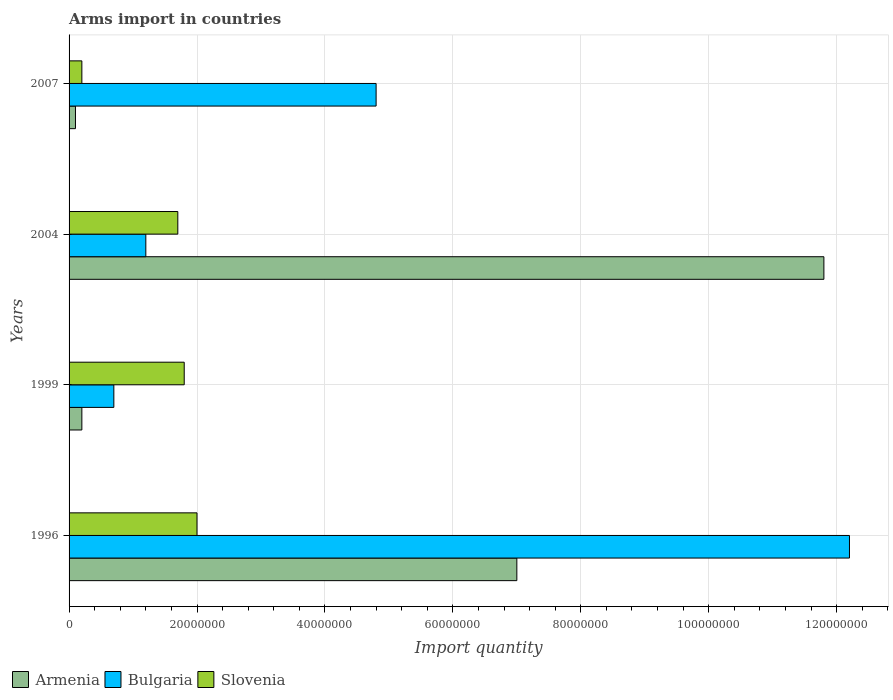How many groups of bars are there?
Your answer should be very brief. 4. Are the number of bars per tick equal to the number of legend labels?
Offer a terse response. Yes. How many bars are there on the 4th tick from the top?
Your answer should be compact. 3. How many bars are there on the 1st tick from the bottom?
Provide a succinct answer. 3. What is the label of the 3rd group of bars from the top?
Provide a succinct answer. 1999. What is the total arms import in Slovenia in 1999?
Offer a terse response. 1.80e+07. Across all years, what is the maximum total arms import in Armenia?
Your answer should be compact. 1.18e+08. Across all years, what is the minimum total arms import in Armenia?
Provide a short and direct response. 1.00e+06. In which year was the total arms import in Bulgaria maximum?
Make the answer very short. 1996. What is the total total arms import in Armenia in the graph?
Your answer should be compact. 1.91e+08. What is the difference between the total arms import in Armenia in 1999 and that in 2007?
Your response must be concise. 1.00e+06. What is the difference between the total arms import in Bulgaria in 2004 and the total arms import in Slovenia in 1999?
Offer a terse response. -6.00e+06. What is the average total arms import in Slovenia per year?
Your answer should be very brief. 1.42e+07. In the year 2004, what is the difference between the total arms import in Slovenia and total arms import in Armenia?
Provide a succinct answer. -1.01e+08. What is the ratio of the total arms import in Armenia in 2004 to that in 2007?
Keep it short and to the point. 118. What is the difference between the highest and the lowest total arms import in Armenia?
Your response must be concise. 1.17e+08. In how many years, is the total arms import in Bulgaria greater than the average total arms import in Bulgaria taken over all years?
Your response must be concise. 2. Is the sum of the total arms import in Slovenia in 1999 and 2004 greater than the maximum total arms import in Armenia across all years?
Your response must be concise. No. What does the 3rd bar from the top in 2004 represents?
Ensure brevity in your answer.  Armenia. Is it the case that in every year, the sum of the total arms import in Armenia and total arms import in Bulgaria is greater than the total arms import in Slovenia?
Your response must be concise. No. How many years are there in the graph?
Make the answer very short. 4. What is the difference between two consecutive major ticks on the X-axis?
Ensure brevity in your answer.  2.00e+07. Are the values on the major ticks of X-axis written in scientific E-notation?
Give a very brief answer. No. Does the graph contain grids?
Provide a short and direct response. Yes. How many legend labels are there?
Make the answer very short. 3. What is the title of the graph?
Make the answer very short. Arms import in countries. Does "Barbados" appear as one of the legend labels in the graph?
Your answer should be compact. No. What is the label or title of the X-axis?
Ensure brevity in your answer.  Import quantity. What is the label or title of the Y-axis?
Your answer should be very brief. Years. What is the Import quantity of Armenia in 1996?
Your answer should be compact. 7.00e+07. What is the Import quantity in Bulgaria in 1996?
Provide a succinct answer. 1.22e+08. What is the Import quantity in Bulgaria in 1999?
Your answer should be compact. 7.00e+06. What is the Import quantity of Slovenia in 1999?
Your response must be concise. 1.80e+07. What is the Import quantity of Armenia in 2004?
Keep it short and to the point. 1.18e+08. What is the Import quantity in Bulgaria in 2004?
Offer a terse response. 1.20e+07. What is the Import quantity in Slovenia in 2004?
Ensure brevity in your answer.  1.70e+07. What is the Import quantity in Armenia in 2007?
Keep it short and to the point. 1.00e+06. What is the Import quantity in Bulgaria in 2007?
Ensure brevity in your answer.  4.80e+07. Across all years, what is the maximum Import quantity of Armenia?
Offer a terse response. 1.18e+08. Across all years, what is the maximum Import quantity in Bulgaria?
Your answer should be compact. 1.22e+08. Across all years, what is the maximum Import quantity in Slovenia?
Make the answer very short. 2.00e+07. Across all years, what is the minimum Import quantity of Bulgaria?
Your answer should be very brief. 7.00e+06. What is the total Import quantity of Armenia in the graph?
Provide a short and direct response. 1.91e+08. What is the total Import quantity of Bulgaria in the graph?
Your response must be concise. 1.89e+08. What is the total Import quantity of Slovenia in the graph?
Give a very brief answer. 5.70e+07. What is the difference between the Import quantity of Armenia in 1996 and that in 1999?
Your answer should be very brief. 6.80e+07. What is the difference between the Import quantity of Bulgaria in 1996 and that in 1999?
Your answer should be very brief. 1.15e+08. What is the difference between the Import quantity in Armenia in 1996 and that in 2004?
Ensure brevity in your answer.  -4.80e+07. What is the difference between the Import quantity in Bulgaria in 1996 and that in 2004?
Your answer should be compact. 1.10e+08. What is the difference between the Import quantity of Slovenia in 1996 and that in 2004?
Provide a succinct answer. 3.00e+06. What is the difference between the Import quantity in Armenia in 1996 and that in 2007?
Provide a short and direct response. 6.90e+07. What is the difference between the Import quantity in Bulgaria in 1996 and that in 2007?
Make the answer very short. 7.40e+07. What is the difference between the Import quantity in Slovenia in 1996 and that in 2007?
Give a very brief answer. 1.80e+07. What is the difference between the Import quantity in Armenia in 1999 and that in 2004?
Ensure brevity in your answer.  -1.16e+08. What is the difference between the Import quantity in Bulgaria in 1999 and that in 2004?
Your response must be concise. -5.00e+06. What is the difference between the Import quantity of Slovenia in 1999 and that in 2004?
Offer a terse response. 1.00e+06. What is the difference between the Import quantity of Armenia in 1999 and that in 2007?
Your answer should be compact. 1.00e+06. What is the difference between the Import quantity of Bulgaria in 1999 and that in 2007?
Offer a terse response. -4.10e+07. What is the difference between the Import quantity in Slovenia in 1999 and that in 2007?
Keep it short and to the point. 1.60e+07. What is the difference between the Import quantity in Armenia in 2004 and that in 2007?
Make the answer very short. 1.17e+08. What is the difference between the Import quantity in Bulgaria in 2004 and that in 2007?
Offer a very short reply. -3.60e+07. What is the difference between the Import quantity in Slovenia in 2004 and that in 2007?
Offer a terse response. 1.50e+07. What is the difference between the Import quantity in Armenia in 1996 and the Import quantity in Bulgaria in 1999?
Keep it short and to the point. 6.30e+07. What is the difference between the Import quantity in Armenia in 1996 and the Import quantity in Slovenia in 1999?
Offer a terse response. 5.20e+07. What is the difference between the Import quantity in Bulgaria in 1996 and the Import quantity in Slovenia in 1999?
Your answer should be compact. 1.04e+08. What is the difference between the Import quantity of Armenia in 1996 and the Import quantity of Bulgaria in 2004?
Make the answer very short. 5.80e+07. What is the difference between the Import quantity of Armenia in 1996 and the Import quantity of Slovenia in 2004?
Give a very brief answer. 5.30e+07. What is the difference between the Import quantity in Bulgaria in 1996 and the Import quantity in Slovenia in 2004?
Your answer should be compact. 1.05e+08. What is the difference between the Import quantity of Armenia in 1996 and the Import quantity of Bulgaria in 2007?
Your answer should be compact. 2.20e+07. What is the difference between the Import quantity in Armenia in 1996 and the Import quantity in Slovenia in 2007?
Your answer should be very brief. 6.80e+07. What is the difference between the Import quantity of Bulgaria in 1996 and the Import quantity of Slovenia in 2007?
Keep it short and to the point. 1.20e+08. What is the difference between the Import quantity of Armenia in 1999 and the Import quantity of Bulgaria in 2004?
Your response must be concise. -1.00e+07. What is the difference between the Import quantity of Armenia in 1999 and the Import quantity of Slovenia in 2004?
Keep it short and to the point. -1.50e+07. What is the difference between the Import quantity in Bulgaria in 1999 and the Import quantity in Slovenia in 2004?
Offer a very short reply. -1.00e+07. What is the difference between the Import quantity of Armenia in 1999 and the Import quantity of Bulgaria in 2007?
Your answer should be compact. -4.60e+07. What is the difference between the Import quantity of Armenia in 1999 and the Import quantity of Slovenia in 2007?
Your answer should be compact. 0. What is the difference between the Import quantity in Armenia in 2004 and the Import quantity in Bulgaria in 2007?
Provide a short and direct response. 7.00e+07. What is the difference between the Import quantity of Armenia in 2004 and the Import quantity of Slovenia in 2007?
Offer a very short reply. 1.16e+08. What is the average Import quantity of Armenia per year?
Give a very brief answer. 4.78e+07. What is the average Import quantity in Bulgaria per year?
Ensure brevity in your answer.  4.72e+07. What is the average Import quantity in Slovenia per year?
Provide a succinct answer. 1.42e+07. In the year 1996, what is the difference between the Import quantity of Armenia and Import quantity of Bulgaria?
Ensure brevity in your answer.  -5.20e+07. In the year 1996, what is the difference between the Import quantity of Armenia and Import quantity of Slovenia?
Your answer should be compact. 5.00e+07. In the year 1996, what is the difference between the Import quantity of Bulgaria and Import quantity of Slovenia?
Your response must be concise. 1.02e+08. In the year 1999, what is the difference between the Import quantity in Armenia and Import quantity in Bulgaria?
Ensure brevity in your answer.  -5.00e+06. In the year 1999, what is the difference between the Import quantity in Armenia and Import quantity in Slovenia?
Offer a very short reply. -1.60e+07. In the year 1999, what is the difference between the Import quantity of Bulgaria and Import quantity of Slovenia?
Offer a terse response. -1.10e+07. In the year 2004, what is the difference between the Import quantity in Armenia and Import quantity in Bulgaria?
Your answer should be compact. 1.06e+08. In the year 2004, what is the difference between the Import quantity of Armenia and Import quantity of Slovenia?
Keep it short and to the point. 1.01e+08. In the year 2004, what is the difference between the Import quantity of Bulgaria and Import quantity of Slovenia?
Your answer should be compact. -5.00e+06. In the year 2007, what is the difference between the Import quantity in Armenia and Import quantity in Bulgaria?
Provide a short and direct response. -4.70e+07. In the year 2007, what is the difference between the Import quantity of Bulgaria and Import quantity of Slovenia?
Provide a succinct answer. 4.60e+07. What is the ratio of the Import quantity in Armenia in 1996 to that in 1999?
Keep it short and to the point. 35. What is the ratio of the Import quantity of Bulgaria in 1996 to that in 1999?
Your answer should be very brief. 17.43. What is the ratio of the Import quantity of Armenia in 1996 to that in 2004?
Keep it short and to the point. 0.59. What is the ratio of the Import quantity of Bulgaria in 1996 to that in 2004?
Keep it short and to the point. 10.17. What is the ratio of the Import quantity of Slovenia in 1996 to that in 2004?
Provide a short and direct response. 1.18. What is the ratio of the Import quantity in Armenia in 1996 to that in 2007?
Ensure brevity in your answer.  70. What is the ratio of the Import quantity in Bulgaria in 1996 to that in 2007?
Your answer should be compact. 2.54. What is the ratio of the Import quantity of Armenia in 1999 to that in 2004?
Your answer should be very brief. 0.02. What is the ratio of the Import quantity in Bulgaria in 1999 to that in 2004?
Ensure brevity in your answer.  0.58. What is the ratio of the Import quantity of Slovenia in 1999 to that in 2004?
Provide a succinct answer. 1.06. What is the ratio of the Import quantity in Armenia in 1999 to that in 2007?
Provide a short and direct response. 2. What is the ratio of the Import quantity of Bulgaria in 1999 to that in 2007?
Ensure brevity in your answer.  0.15. What is the ratio of the Import quantity of Armenia in 2004 to that in 2007?
Your answer should be very brief. 118. What is the ratio of the Import quantity of Bulgaria in 2004 to that in 2007?
Your response must be concise. 0.25. What is the difference between the highest and the second highest Import quantity in Armenia?
Provide a succinct answer. 4.80e+07. What is the difference between the highest and the second highest Import quantity in Bulgaria?
Give a very brief answer. 7.40e+07. What is the difference between the highest and the second highest Import quantity of Slovenia?
Provide a short and direct response. 2.00e+06. What is the difference between the highest and the lowest Import quantity in Armenia?
Offer a terse response. 1.17e+08. What is the difference between the highest and the lowest Import quantity in Bulgaria?
Your answer should be very brief. 1.15e+08. What is the difference between the highest and the lowest Import quantity of Slovenia?
Your answer should be compact. 1.80e+07. 